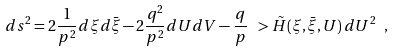Convert formula to latex. <formula><loc_0><loc_0><loc_500><loc_500>d s ^ { 2 } = 2 \frac { 1 } { p ^ { 2 } } d \xi d \bar { \xi } - 2 \frac { q ^ { 2 } } { p ^ { 2 } } d U d V - \frac { q } { p } \ > \tilde { H } ( \xi , \bar { \xi } , U ) \, d U ^ { 2 } \ ,</formula> 